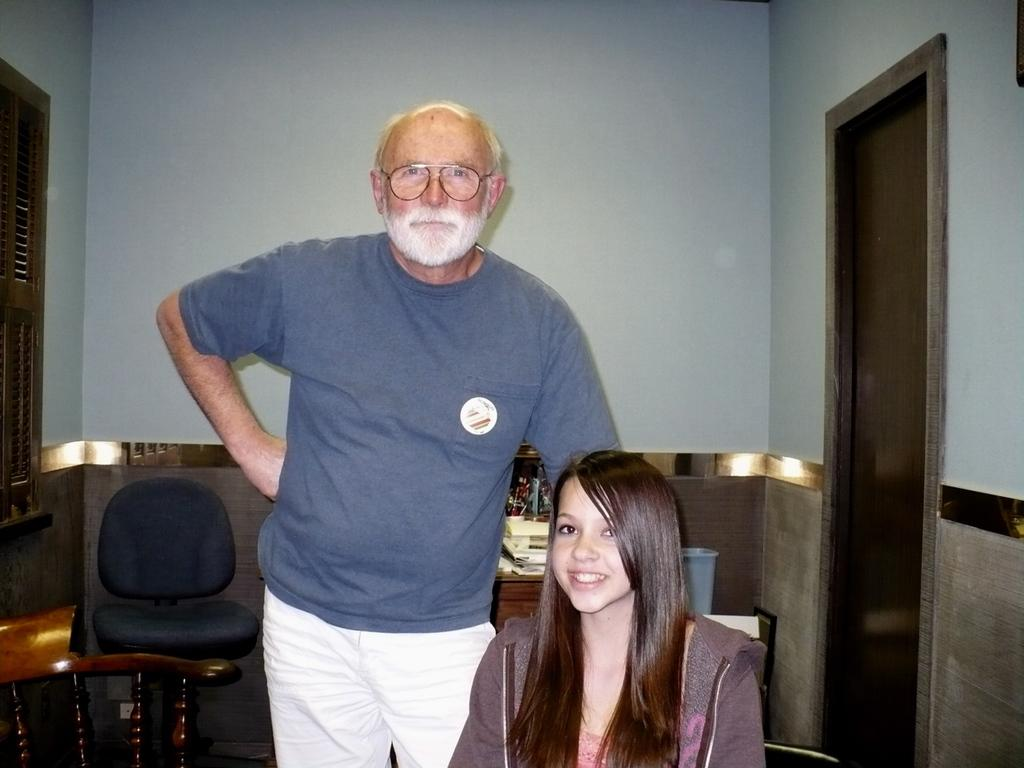What is the man in the image wearing? The man in the image is wearing specs. How is the lady in the image feeling? The lady in the image is smiling, which suggests she is feeling happy or content. What can be seen in the background of the image? There is a chair, a wall, and a door in the background of the image. Can you describe any other items visible in the image? There are some other items in the image, but their specific nature is not mentioned in the provided facts. What type of committee is meeting in the image? There is no committee meeting in the image; it features a man and a lady in close proximity. Can you see any fairies in the image? There are no fairies present in the image. 